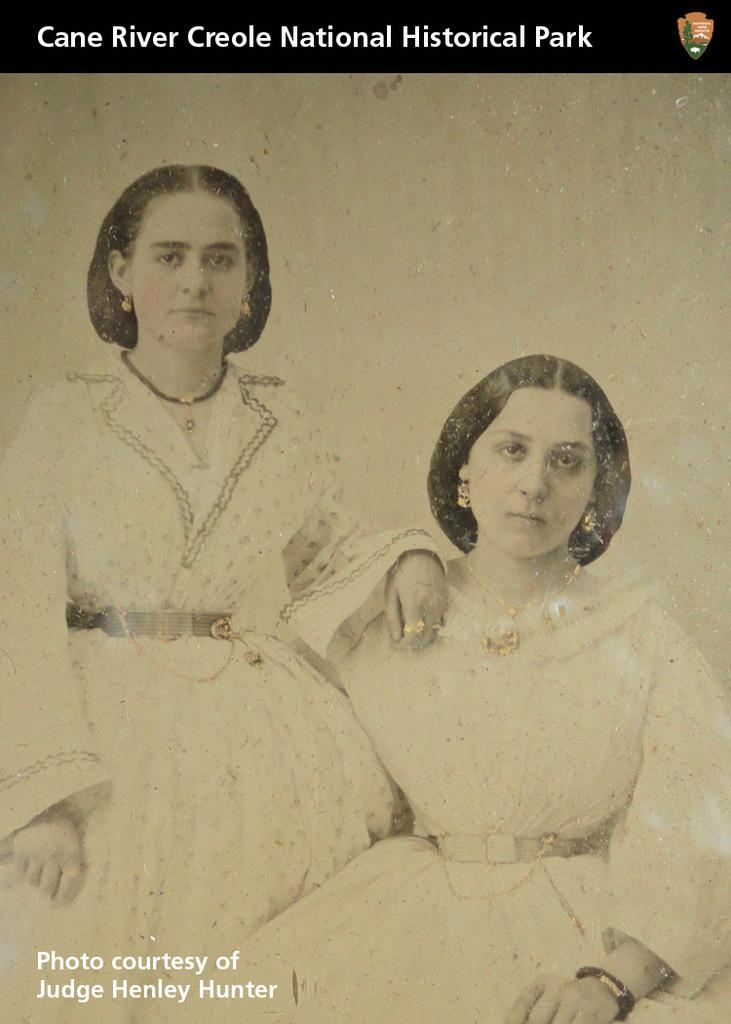What is present on the poster in the image? There is a poster in the image, which features two persons, words, and a logo. Can you describe the content of the poster? The poster contains two persons, words, and a logo. What is the purpose of the logo on the poster? The purpose of the logo on the poster is to represent a brand, organization, or event. Where is the garden located in the image? There is no garden present in the image. What type of army is depicted on the poster? There is no army depicted on the poster; it features two persons, words, and a logo. What type of stove is visible in the image? There is no stove present in the image. 